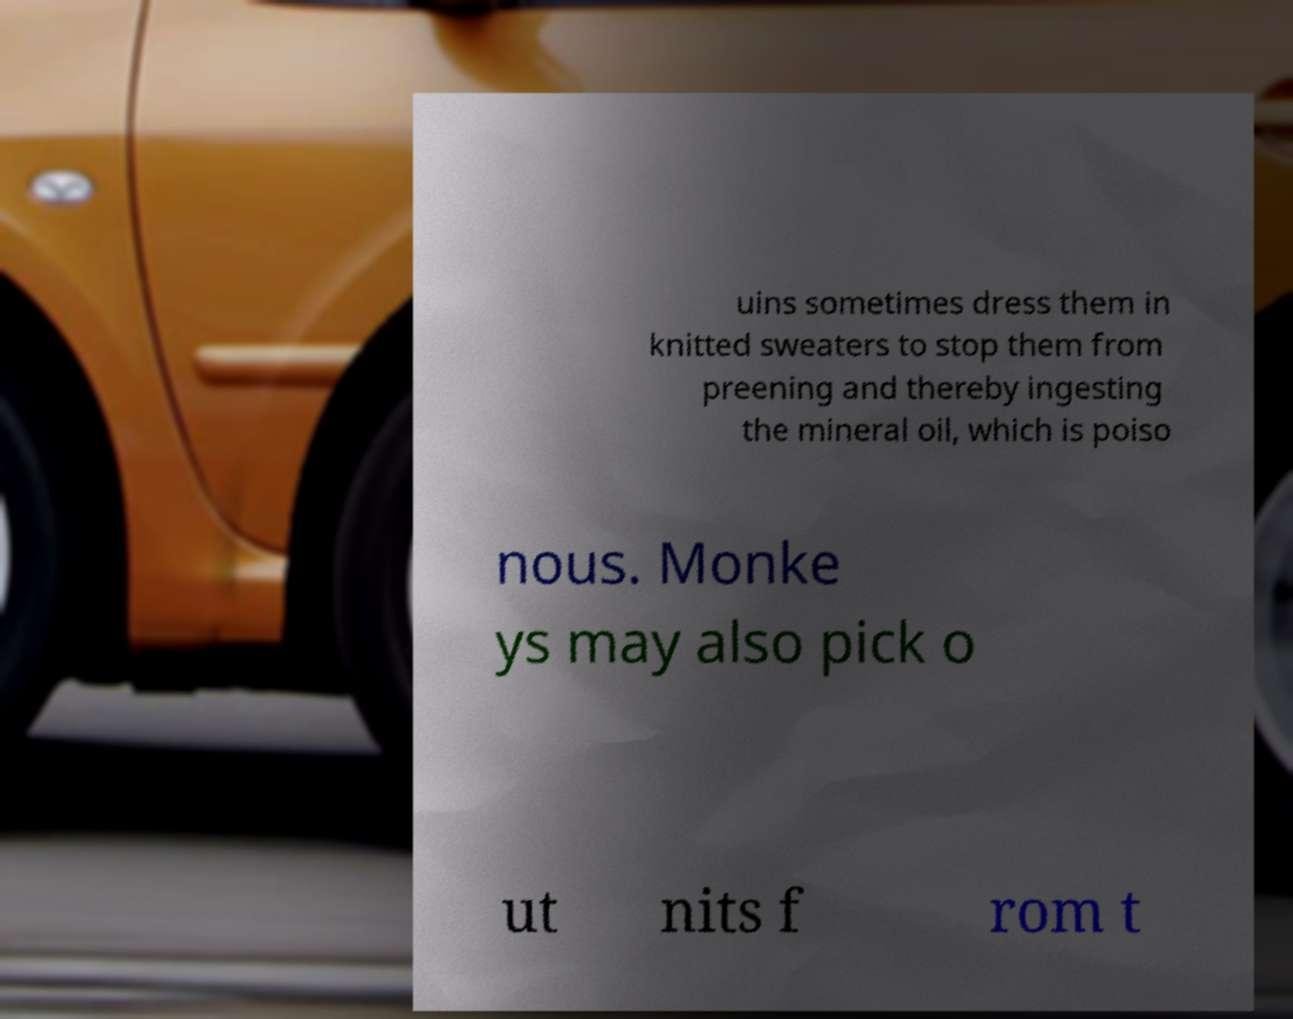Can you read and provide the text displayed in the image?This photo seems to have some interesting text. Can you extract and type it out for me? uins sometimes dress them in knitted sweaters to stop them from preening and thereby ingesting the mineral oil, which is poiso nous. Monke ys may also pick o ut nits f rom t 